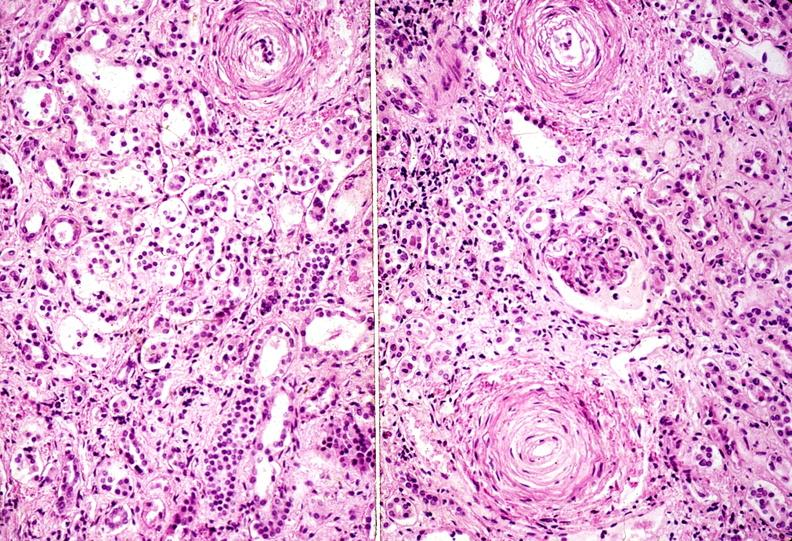where is this?
Answer the question using a single word or phrase. Urinary 